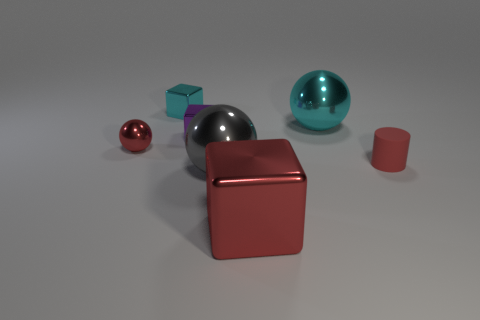There is a rubber cylinder; what number of cyan cubes are on the right side of it?
Your response must be concise. 0. Is the number of big gray matte spheres greater than the number of large gray shiny objects?
Offer a terse response. No. What shape is the shiny object that is both right of the small purple shiny block and behind the tiny red cylinder?
Offer a very short reply. Sphere. Are there any big green rubber things?
Your answer should be very brief. No. What material is the tiny purple thing that is the same shape as the large red metallic thing?
Your response must be concise. Metal. There is a cyan metal object on the right side of the ball that is in front of the red metal object that is behind the matte cylinder; what is its shape?
Give a very brief answer. Sphere. There is a cylinder that is the same color as the small shiny sphere; what material is it?
Your answer should be compact. Rubber. How many matte things have the same shape as the small purple shiny object?
Your response must be concise. 0. Do the small metallic block on the right side of the tiny cyan metallic object and the rubber thing that is on the right side of the large red metallic thing have the same color?
Your answer should be very brief. No. There is a cylinder that is the same size as the cyan cube; what is it made of?
Your response must be concise. Rubber. 